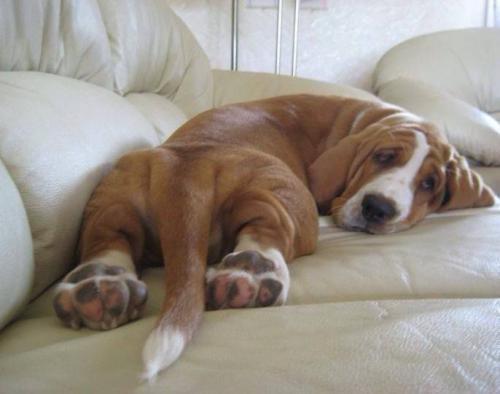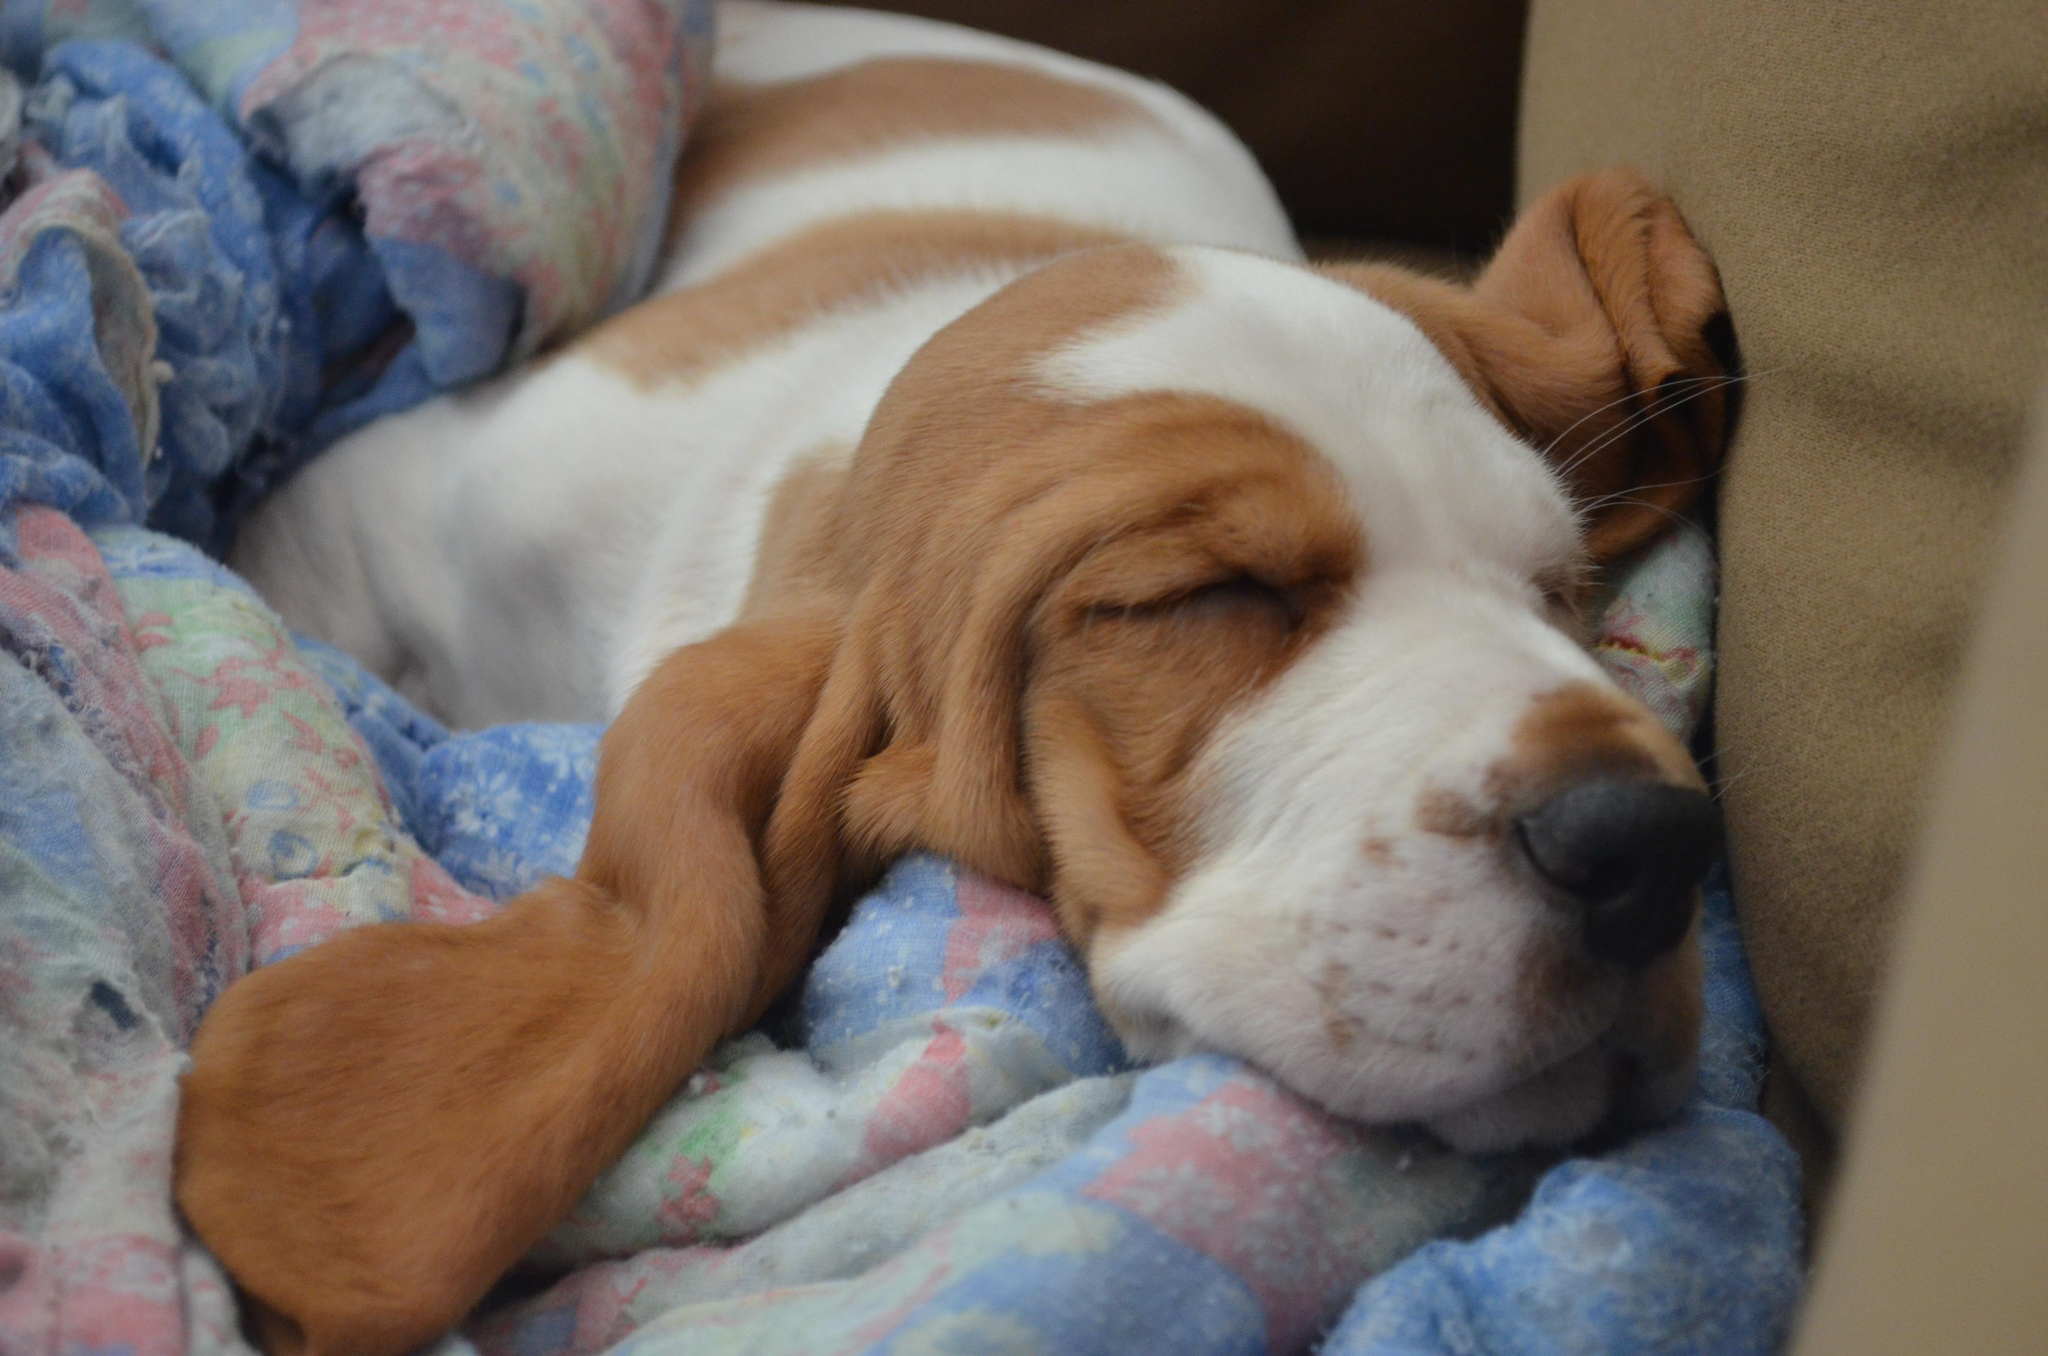The first image is the image on the left, the second image is the image on the right. For the images displayed, is the sentence "on the left picture the dog has their head laying down" factually correct? Answer yes or no. Yes. The first image is the image on the left, the second image is the image on the right. Evaluate the accuracy of this statement regarding the images: "The dog in the left image is laying down.". Is it true? Answer yes or no. Yes. 